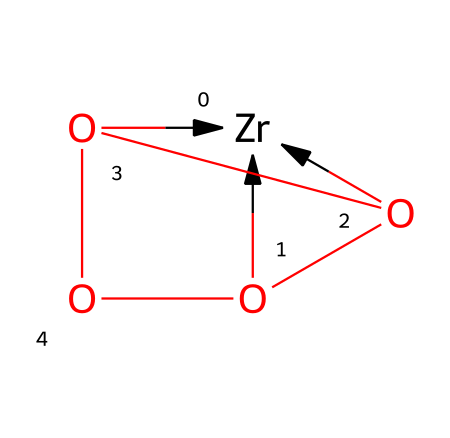how many zirconium atoms are present in the structure? By examining the SMILES notation, we see [Zr] appears once, indicating there is one zirconium atom.
Answer: 1 how many oxygen atoms are present in the structure? In the SMILES representation, [O] appears three times, showing there are three oxygen atoms in the structure.
Answer: 3 what type of crystal structure does zirconia exhibit? Zirconia typically exhibits a tetragonal crystal structure; this is commonly observed in zirconium dioxide.
Answer: tetragonal how does the crystalline structure of zirconia contribute to its durability in jewelry? The strong ionic bonding between zirconium and oxygen, along with the compact tetragonal structure, increases its hardness, making it durable.
Answer: increases hardness why is zirconia often used as a diamond simulant? Zirconia has a high refractive index and excellent dispersion, making it visually similar to diamonds, and it's also more affordable.
Answer: high refractive index what characteristic of zirconia allows it to be used in high-temperature applications? Its high melting point and stability under heat allow zirconia to maintain its structure without deforming or melting.
Answer: high melting point 